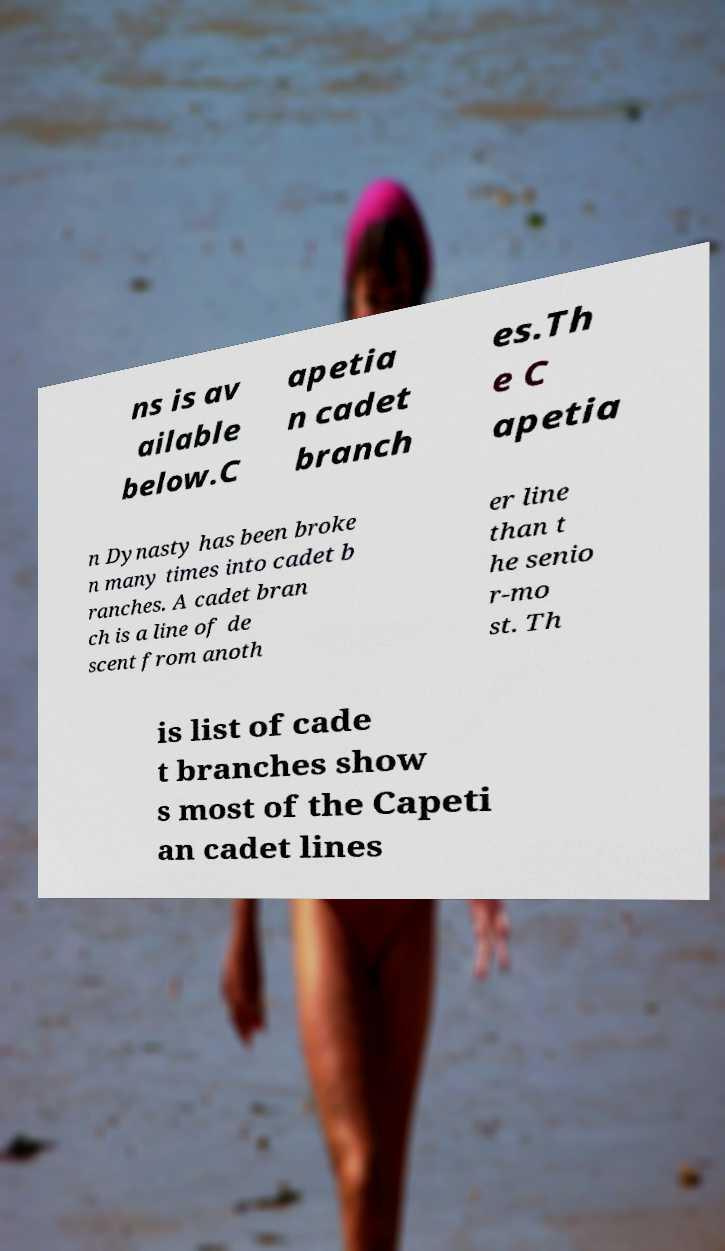Could you assist in decoding the text presented in this image and type it out clearly? ns is av ailable below.C apetia n cadet branch es.Th e C apetia n Dynasty has been broke n many times into cadet b ranches. A cadet bran ch is a line of de scent from anoth er line than t he senio r-mo st. Th is list of cade t branches show s most of the Capeti an cadet lines 